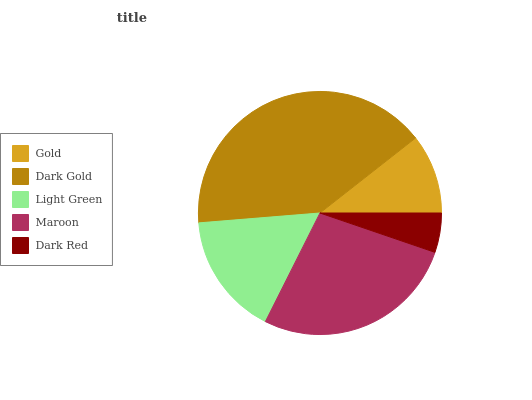Is Dark Red the minimum?
Answer yes or no. Yes. Is Dark Gold the maximum?
Answer yes or no. Yes. Is Light Green the minimum?
Answer yes or no. No. Is Light Green the maximum?
Answer yes or no. No. Is Dark Gold greater than Light Green?
Answer yes or no. Yes. Is Light Green less than Dark Gold?
Answer yes or no. Yes. Is Light Green greater than Dark Gold?
Answer yes or no. No. Is Dark Gold less than Light Green?
Answer yes or no. No. Is Light Green the high median?
Answer yes or no. Yes. Is Light Green the low median?
Answer yes or no. Yes. Is Maroon the high median?
Answer yes or no. No. Is Gold the low median?
Answer yes or no. No. 